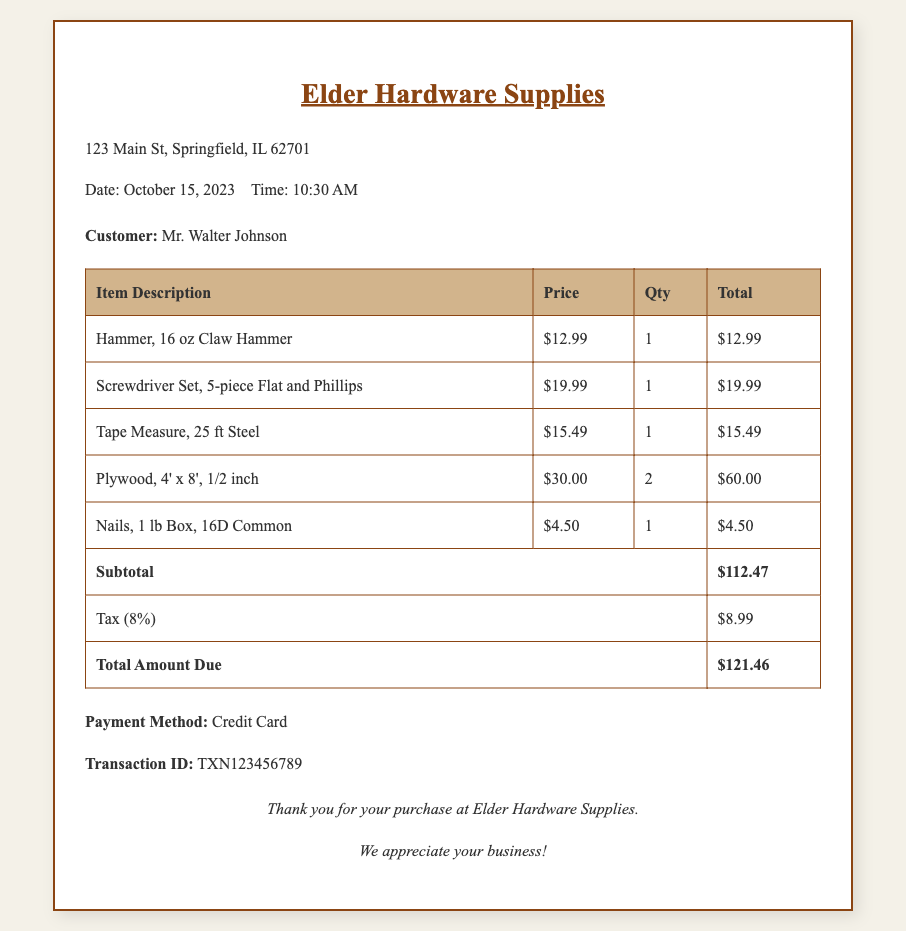What is the store's name? The store's name is prominently displayed at the top of the receipt.
Answer: Elder Hardware Supplies Who is the customer? The customer's name is mentioned in the customer information section.
Answer: Mr. Walter Johnson What is the date of the transaction? The date is specified in the store information section of the receipt.
Answer: October 15, 2023 What is the total amount due? The total amount due is listed at the bottom of the table as the final total.
Answer: $121.46 How many plywood sheets were purchased? The quantity of plywood sheets is indicated in the table under "Qty".
Answer: 2 What is the tax rate applied? The tax rate is mentioned in the tax row of the receipt.
Answer: 8% What type of payment was used? The payment method is clearly stated in the receipt.
Answer: Credit Card What is the transaction ID? The transaction ID is provided for reference in case of queries.
Answer: TXN123456789 What item has the highest price? The highest price can be found within the listed items in the table.
Answer: Plywood, 4' x 8', 1/2 inch What is the subtotal before taxes? The subtotal is given in the table as the amount before applying taxes.
Answer: $112.47 